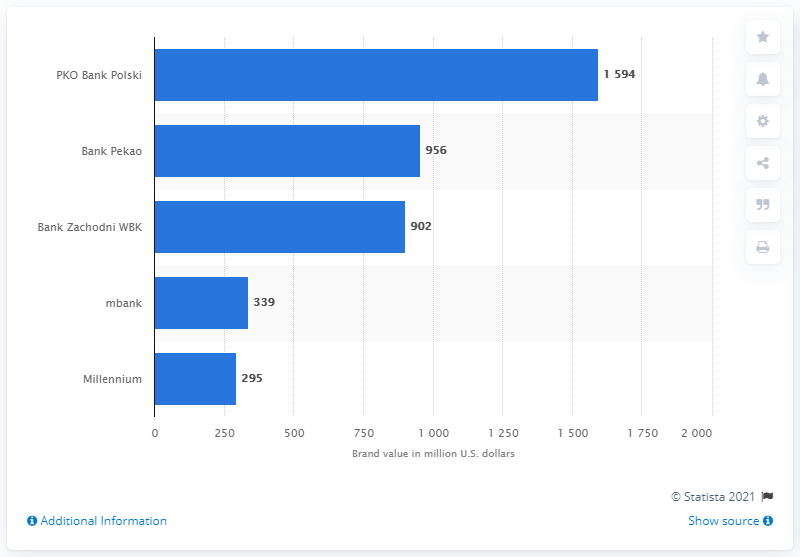Identify some key points in this picture. The brand value of PKO Bank Polski was 1594... The fifth leading bank domiciled in Poland was named Millennium. 